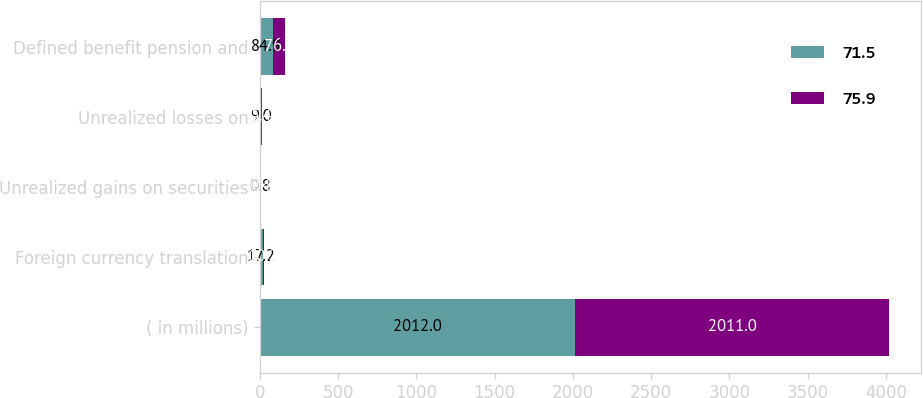<chart> <loc_0><loc_0><loc_500><loc_500><stacked_bar_chart><ecel><fcel>( in millions)<fcel>Foreign currency translation<fcel>Unrealized gains on securities<fcel>Unrealized losses on<fcel>Defined benefit pension and<nl><fcel>71.5<fcel>2012<fcel>17.2<fcel>0.8<fcel>9<fcel>84.9<nl><fcel>75.9<fcel>2011<fcel>10.2<fcel>0.4<fcel>5.4<fcel>76.7<nl></chart> 